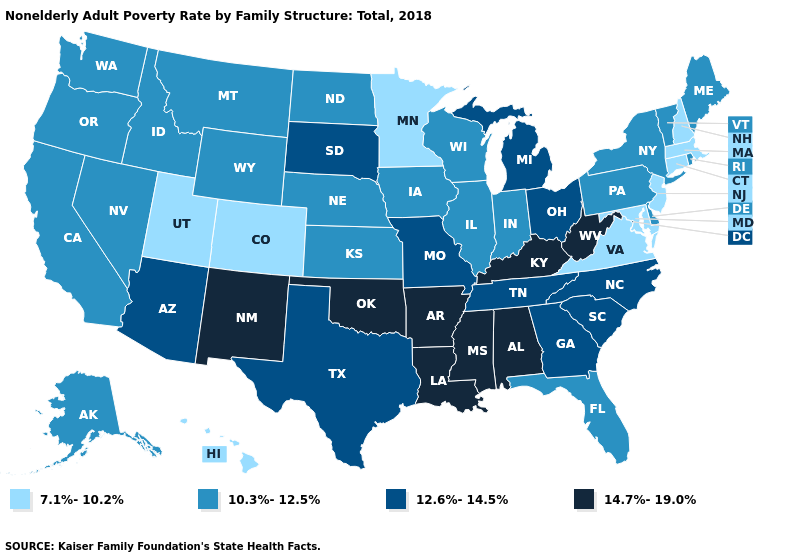What is the lowest value in the USA?
Quick response, please. 7.1%-10.2%. Which states have the highest value in the USA?
Short answer required. Alabama, Arkansas, Kentucky, Louisiana, Mississippi, New Mexico, Oklahoma, West Virginia. Does the first symbol in the legend represent the smallest category?
Quick response, please. Yes. Does the map have missing data?
Keep it brief. No. What is the highest value in states that border New Hampshire?
Keep it brief. 10.3%-12.5%. What is the highest value in states that border Michigan?
Write a very short answer. 12.6%-14.5%. Which states have the lowest value in the MidWest?
Be succinct. Minnesota. Which states have the lowest value in the USA?
Be succinct. Colorado, Connecticut, Hawaii, Maryland, Massachusetts, Minnesota, New Hampshire, New Jersey, Utah, Virginia. Does Colorado have the highest value in the USA?
Answer briefly. No. Among the states that border Indiana , which have the lowest value?
Concise answer only. Illinois. What is the value of Virginia?
Write a very short answer. 7.1%-10.2%. Which states have the highest value in the USA?
Give a very brief answer. Alabama, Arkansas, Kentucky, Louisiana, Mississippi, New Mexico, Oklahoma, West Virginia. Among the states that border Alabama , which have the lowest value?
Short answer required. Florida. Does North Dakota have a lower value than Texas?
Short answer required. Yes. Does the map have missing data?
Short answer required. No. 